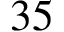<formula> <loc_0><loc_0><loc_500><loc_500>3 5</formula> 